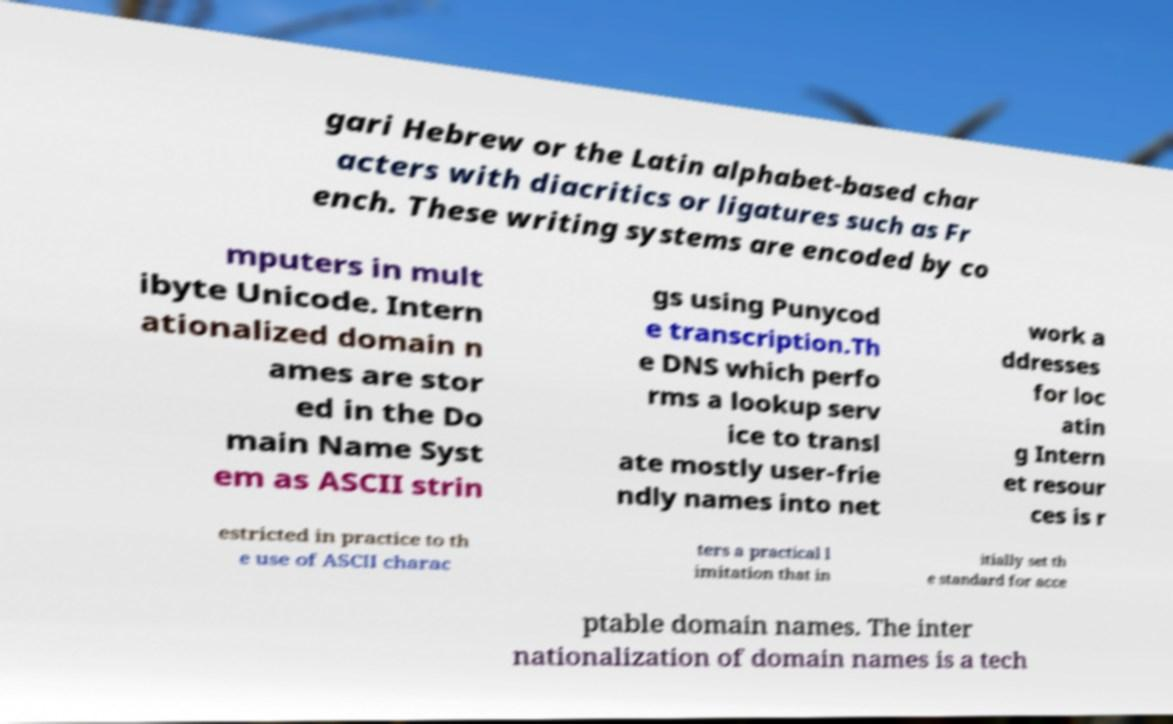Please read and relay the text visible in this image. What does it say? gari Hebrew or the Latin alphabet-based char acters with diacritics or ligatures such as Fr ench. These writing systems are encoded by co mputers in mult ibyte Unicode. Intern ationalized domain n ames are stor ed in the Do main Name Syst em as ASCII strin gs using Punycod e transcription.Th e DNS which perfo rms a lookup serv ice to transl ate mostly user-frie ndly names into net work a ddresses for loc atin g Intern et resour ces is r estricted in practice to th e use of ASCII charac ters a practical l imitation that in itially set th e standard for acce ptable domain names. The inter nationalization of domain names is a tech 